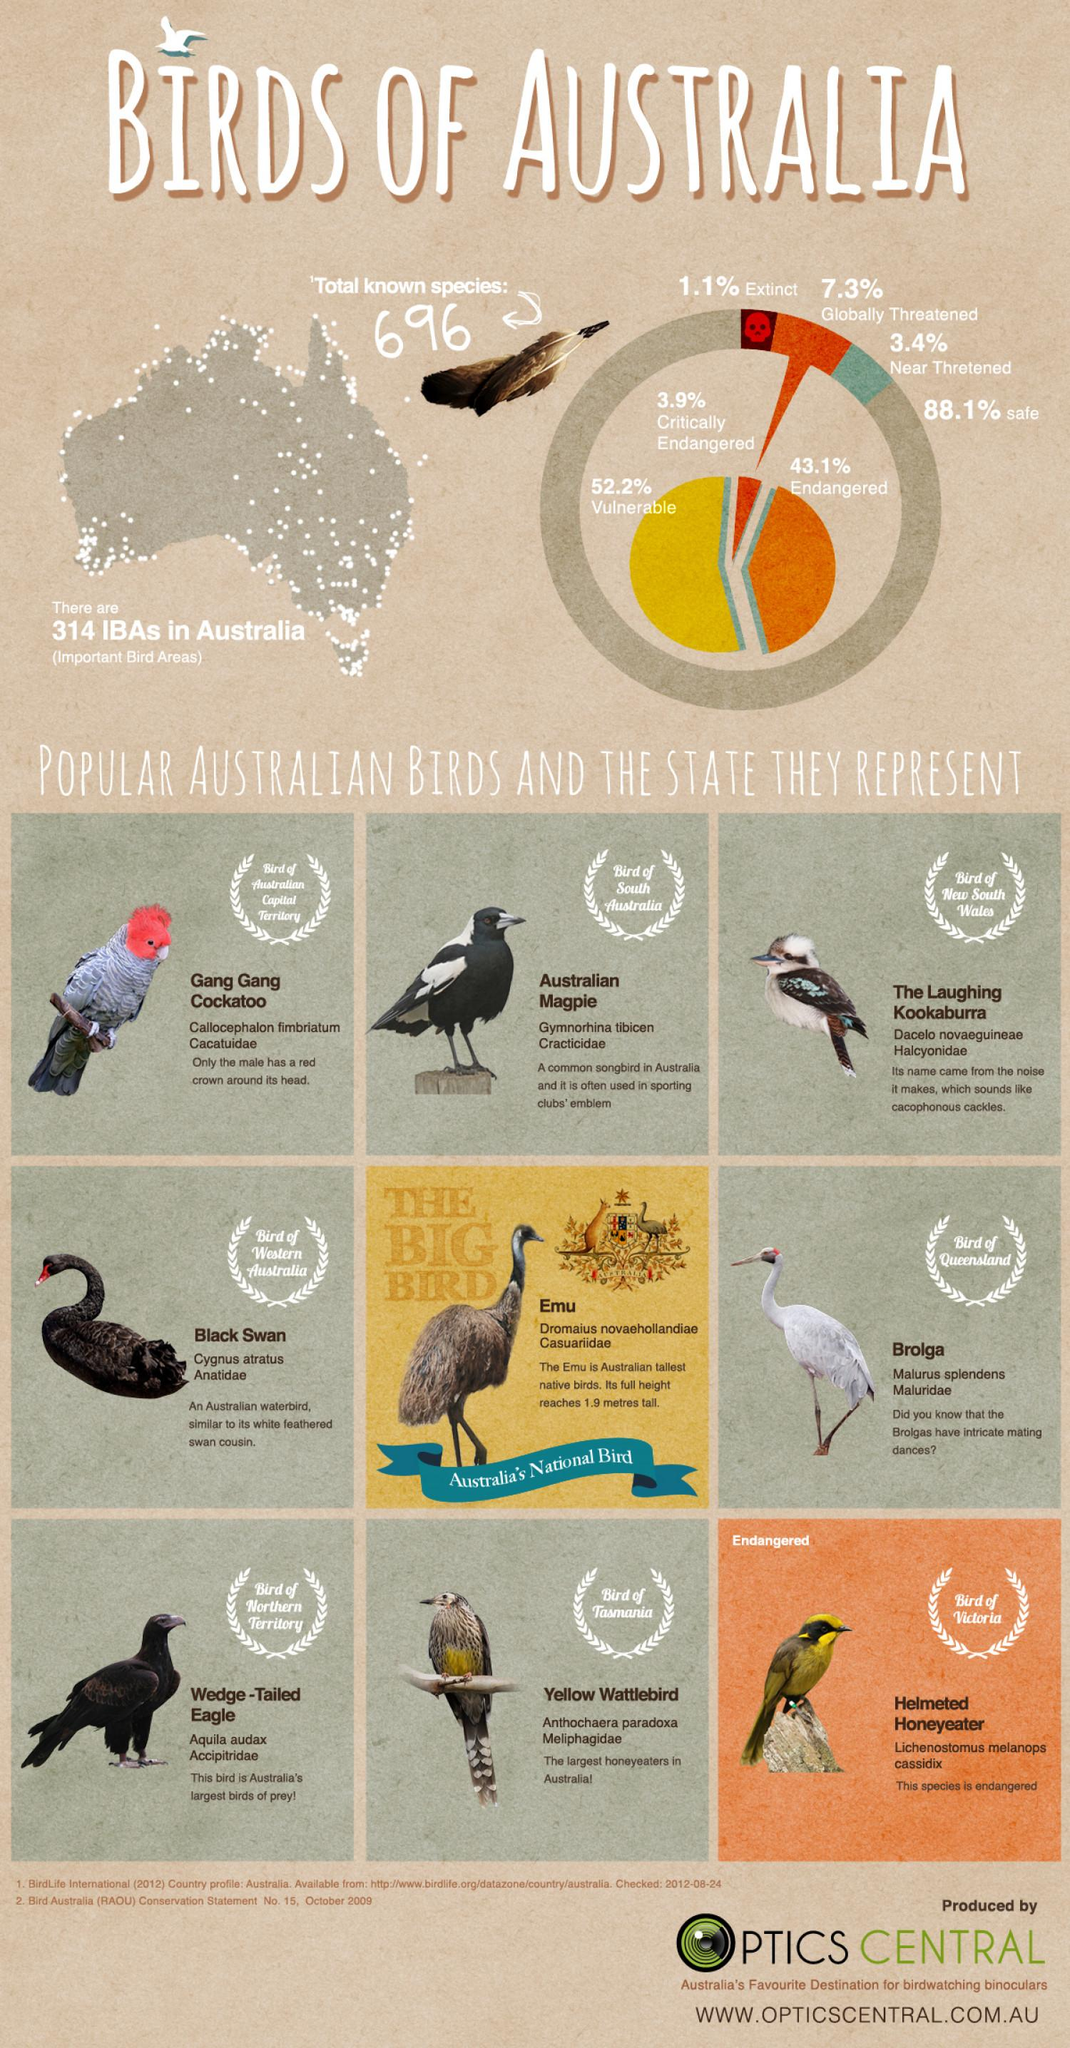Highlight a few significant elements in this photo. The document lists 9 birds. The bird belonging to South Australia is the Australian Magpie. The yellow wattlebird is the bird that consumes the most honey in Australia. The total percentage of globally and near threatened birds is 10.7%. 